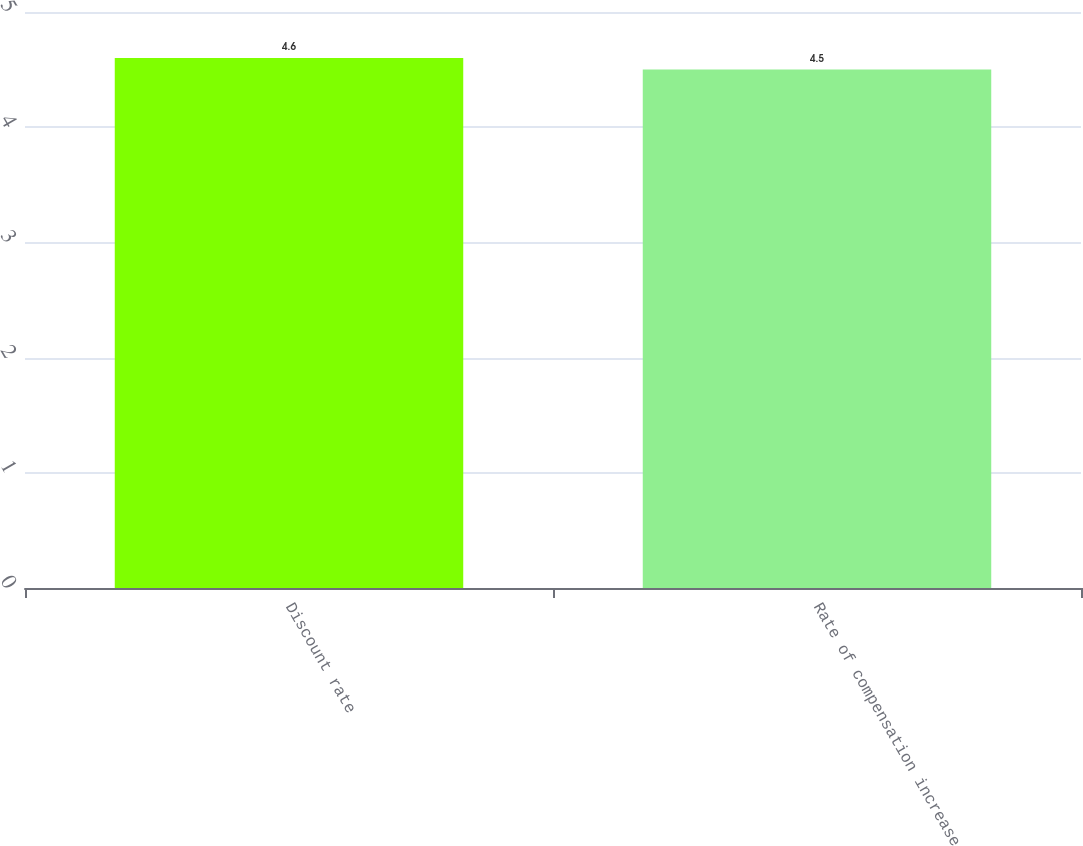Convert chart to OTSL. <chart><loc_0><loc_0><loc_500><loc_500><bar_chart><fcel>Discount rate<fcel>Rate of compensation increase<nl><fcel>4.6<fcel>4.5<nl></chart> 